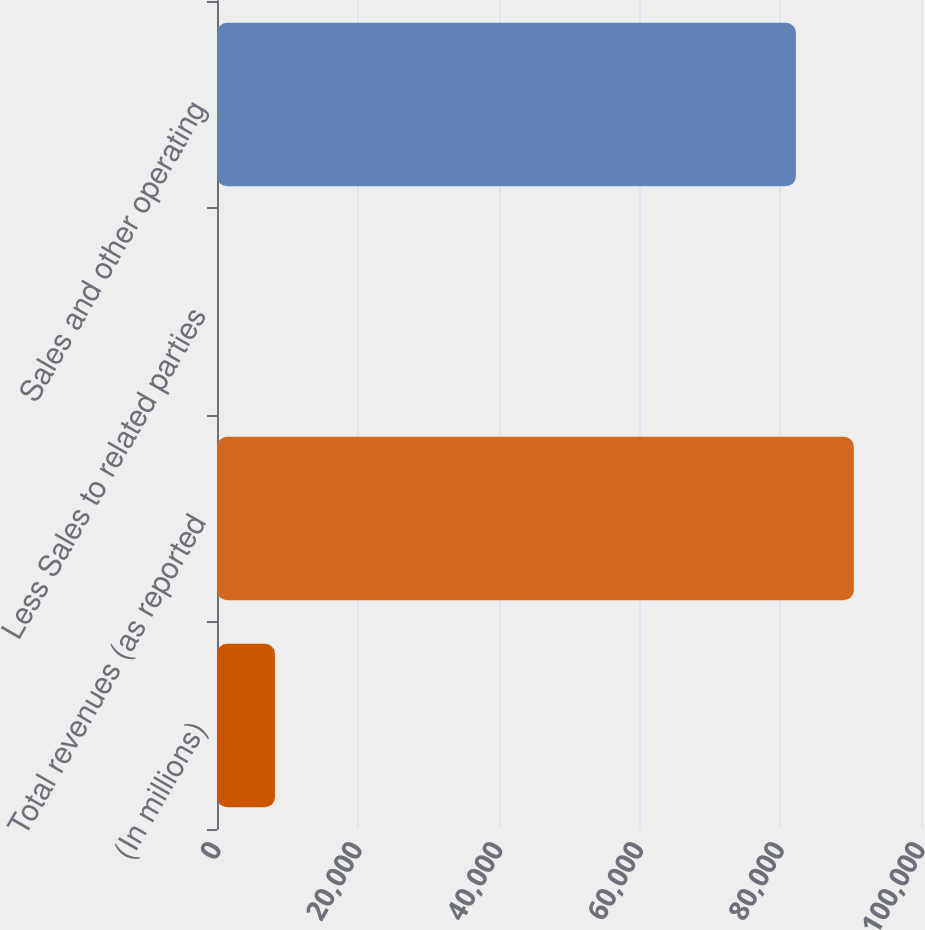Convert chart to OTSL. <chart><loc_0><loc_0><loc_500><loc_500><bar_chart><fcel>(In millions)<fcel>Total revenues (as reported<fcel>Less Sales to related parties<fcel>Sales and other operating<nl><fcel>8231.7<fcel>90458.7<fcel>8<fcel>82235<nl></chart> 